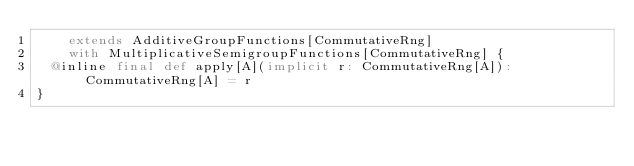<code> <loc_0><loc_0><loc_500><loc_500><_Scala_>    extends AdditiveGroupFunctions[CommutativeRng]
    with MultiplicativeSemigroupFunctions[CommutativeRng] {
  @inline final def apply[A](implicit r: CommutativeRng[A]): CommutativeRng[A] = r
}
</code> 